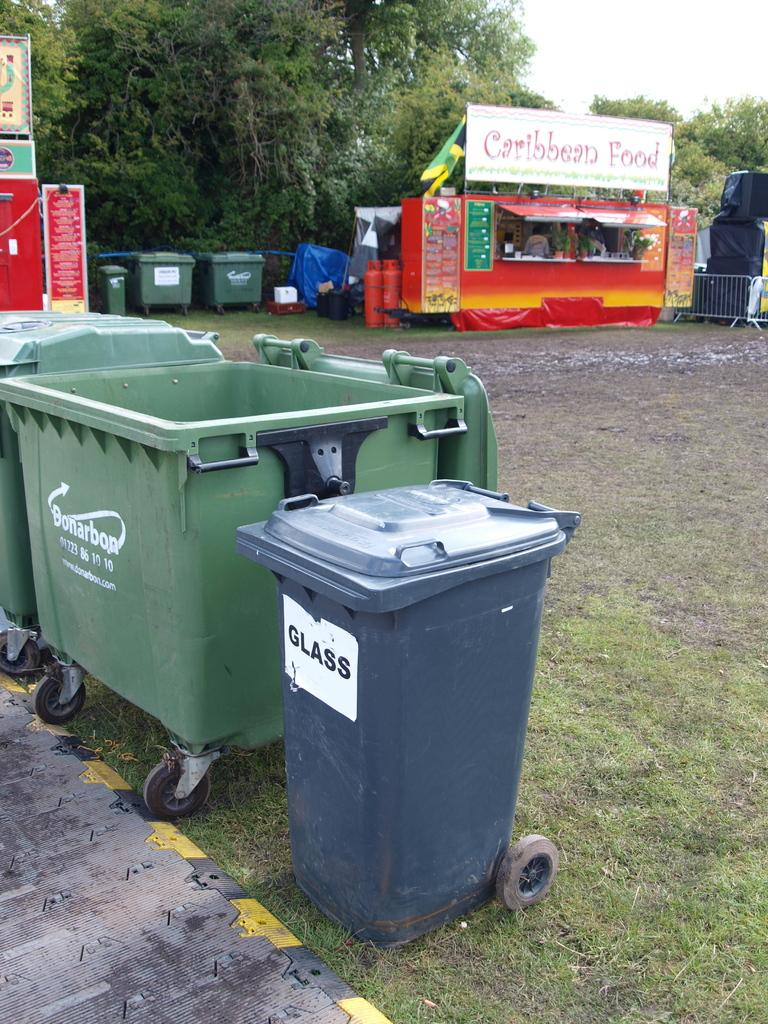<image>
Present a compact description of the photo's key features. A set of trash cans sit near a Caribbean food stand. 